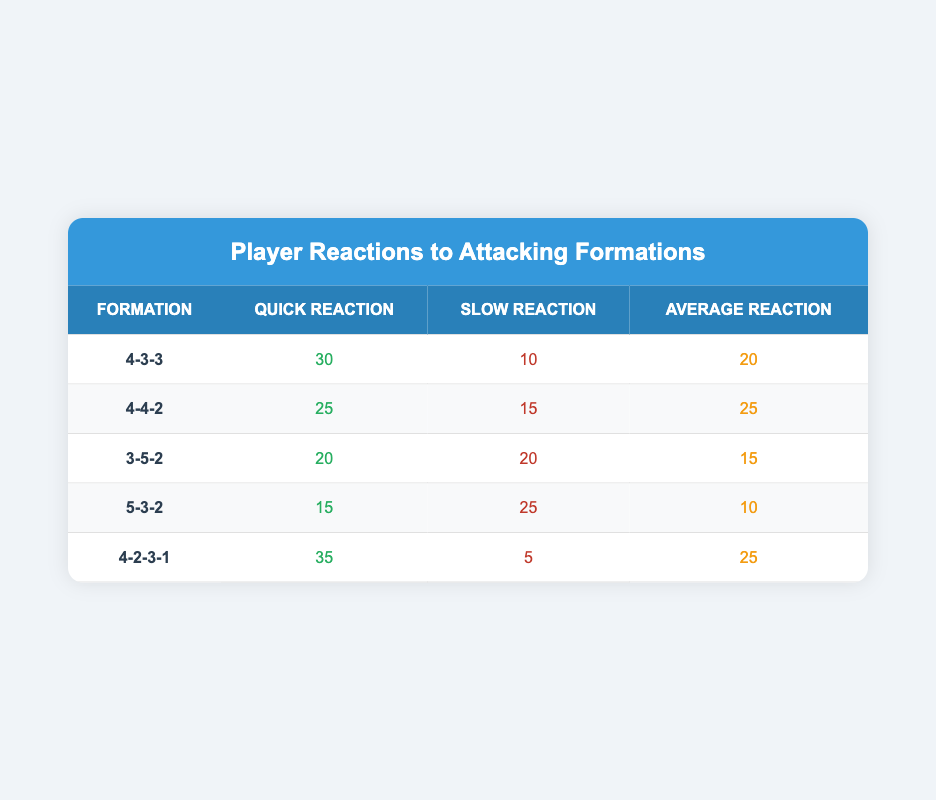What is the quick reaction value for the 4-4-2 formation? The quick reaction value for the 4-4-2 formation is listed in the table, specifically in the second row under the "Quick Reaction" column. The value is 25.
Answer: 25 Which formation has the lowest average reaction time? To find the lowest average reaction time, we compare the values in the "Average Reaction" column for each formation. The values are 20, 25, 15, 10, and 25, and the lowest among these is 10 for the 5-3-2 formation.
Answer: 5-3-2 What is the sum of quick reactions for all formations? We can calculate the sum by adding the quick reaction values from the "Quick Reaction" column for all formations: 30 + 25 + 20 + 15 + 35 = 125.
Answer: 125 Is the quick reaction for the 4-2-3-1 formation greater than the slow reaction for the same formation? The quick reaction for the 4-2-3-1 formation is 35, while the slow reaction is 5. Since 35 is greater than 5, the statement is true.
Answer: Yes Which formation has the highest slow reaction value, and what is that value? We need to check the "Slow Reaction" column for the highest value. The values are 10, 15, 20, 25, and 5, with the highest being 25 for the 5-3-2 formation.
Answer: 5-3-2, 25 What is the difference in average reaction times between the best and the worst formation? The formation with the best average reaction time is 4-4-2 with 25, and the worst is 5-3-2 with 10. The difference is calculated as 25 - 10 = 15.
Answer: 15 Which formation showed a better quick reaction than its slow reaction? A quick comparison of both reactions reveals that the formations 4-3-3 (quick 30 vs slow 10), 4-4-2 (quick 25 vs slow 15), and 4-2-3-1 (quick 35 vs slow 5) all have quick reactions greater than their slow reactions.
Answer: 4-3-3, 4-4-2, 4-2-3-1 How many formations have average reactions greater than 20? The average reaction values are 20, 25, 15, 10, and 25. Only the 4-4-2 and 4-2-3-1 formations have average reactions greater than 20. Therefore, there are two formations.
Answer: 2 What is the average of the slow reaction values across all formations? To find the average, we sum the slow reaction values: 10 + 15 + 20 + 25 + 5 = 75. There are 5 formations, so we divide by 5 to get the average: 75 / 5 = 15.
Answer: 15 